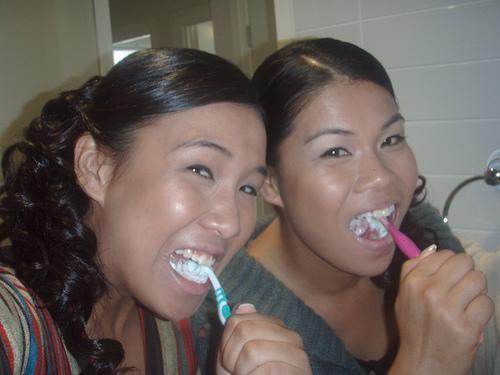How many people are there?
Give a very brief answer. 2. How many girls are shown?
Give a very brief answer. 2. How many people are pictured here?
Give a very brief answer. 2. How many women are in the photo?
Give a very brief answer. 2. How many people are brushing teeth?
Give a very brief answer. 2. How many women in the photo have black hair?
Give a very brief answer. 2. How many people are visible?
Give a very brief answer. 2. How many chairs are on the left side of the table?
Give a very brief answer. 0. 